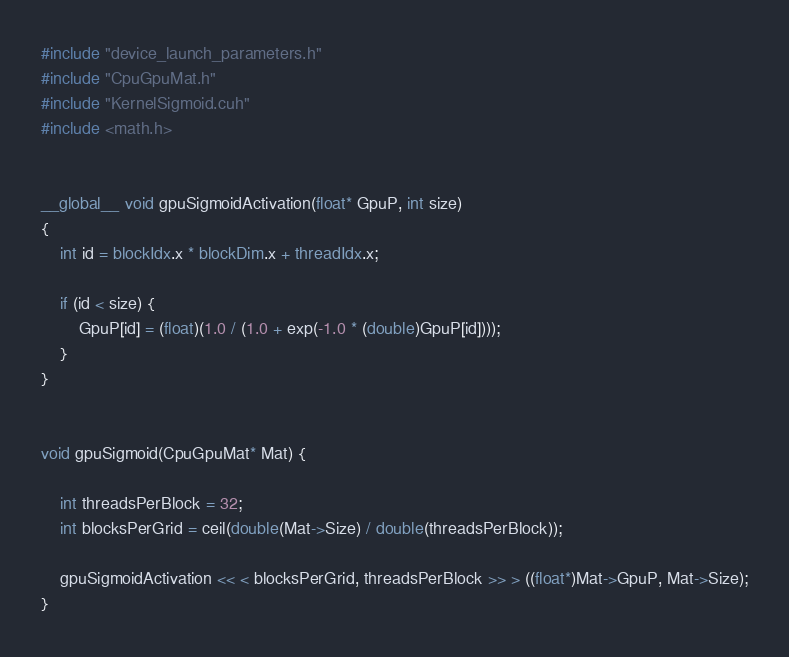Convert code to text. <code><loc_0><loc_0><loc_500><loc_500><_Cuda_>#include "device_launch_parameters.h"
#include "CpuGpuMat.h"
#include "KernelSigmoid.cuh"
#include <math.h>


__global__ void gpuSigmoidActivation(float* GpuP, int size)
{
	int id = blockIdx.x * blockDim.x + threadIdx.x;

	if (id < size) {
		GpuP[id] = (float)(1.0 / (1.0 + exp(-1.0 * (double)GpuP[id])));
	}
}


void gpuSigmoid(CpuGpuMat* Mat) {

	int threadsPerBlock = 32;
	int blocksPerGrid = ceil(double(Mat->Size) / double(threadsPerBlock));

	gpuSigmoidActivation << < blocksPerGrid, threadsPerBlock >> > ((float*)Mat->GpuP, Mat->Size);
}
</code> 